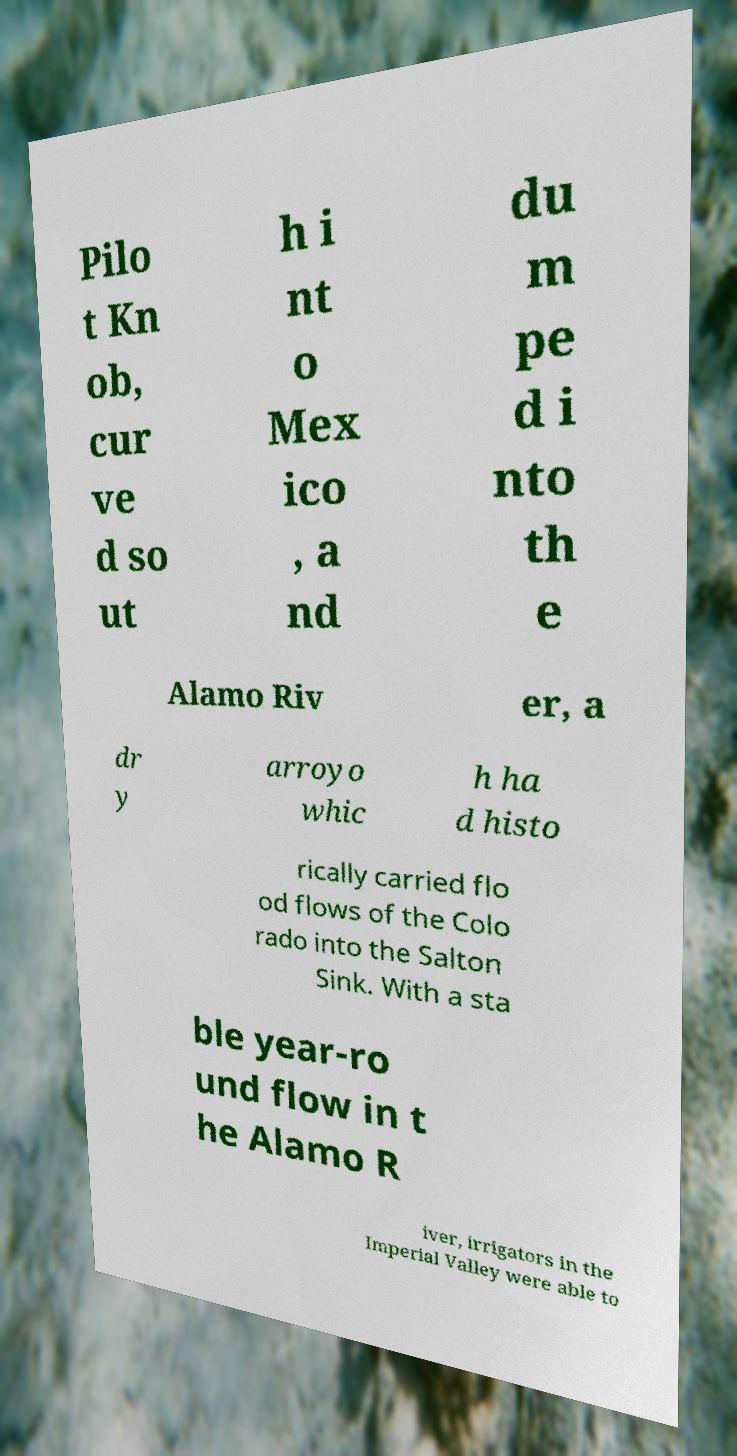Could you assist in decoding the text presented in this image and type it out clearly? Pilo t Kn ob, cur ve d so ut h i nt o Mex ico , a nd du m pe d i nto th e Alamo Riv er, a dr y arroyo whic h ha d histo rically carried flo od flows of the Colo rado into the Salton Sink. With a sta ble year-ro und flow in t he Alamo R iver, irrigators in the Imperial Valley were able to 